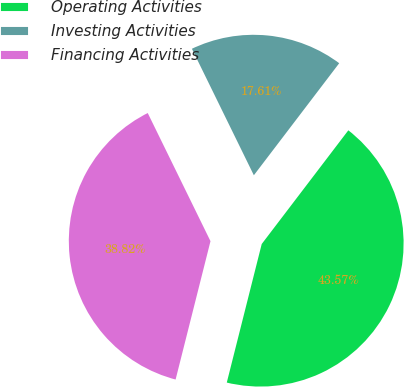Convert chart to OTSL. <chart><loc_0><loc_0><loc_500><loc_500><pie_chart><fcel>Operating Activities<fcel>Investing Activities<fcel>Financing Activities<nl><fcel>43.57%<fcel>17.61%<fcel>38.82%<nl></chart> 